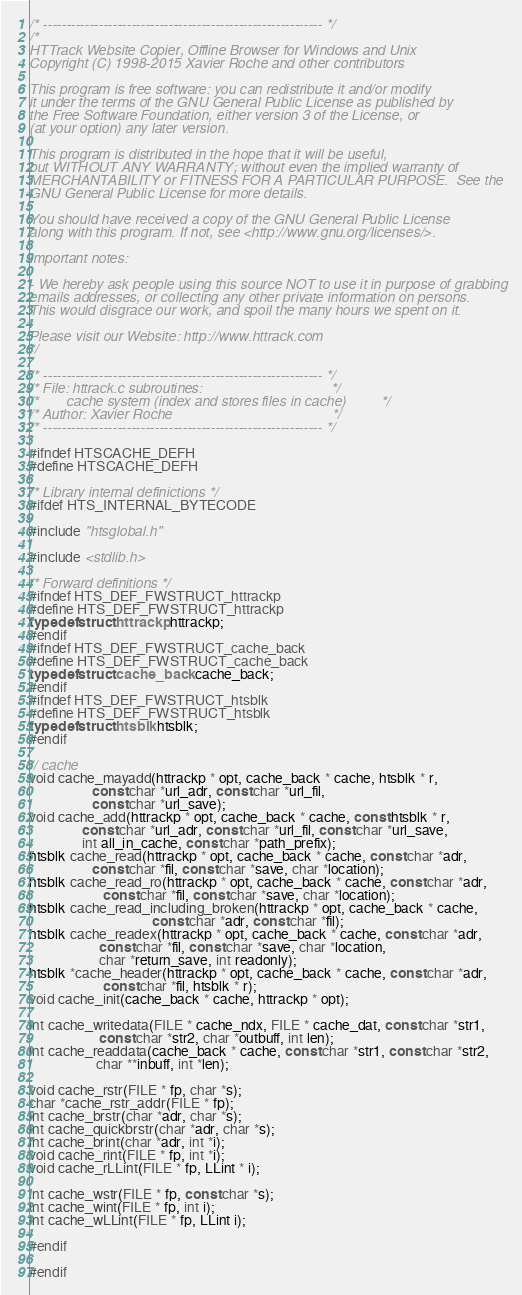Convert code to text. <code><loc_0><loc_0><loc_500><loc_500><_C_>/* ------------------------------------------------------------ */
/*
HTTrack Website Copier, Offline Browser for Windows and Unix
Copyright (C) 1998-2015 Xavier Roche and other contributors

This program is free software: you can redistribute it and/or modify
it under the terms of the GNU General Public License as published by
the Free Software Foundation, either version 3 of the License, or
(at your option) any later version.

This program is distributed in the hope that it will be useful,
but WITHOUT ANY WARRANTY; without even the implied warranty of
MERCHANTABILITY or FITNESS FOR A PARTICULAR PURPOSE.  See the
GNU General Public License for more details.

You should have received a copy of the GNU General Public License
along with this program. If not, see <http://www.gnu.org/licenses/>.

Important notes:

- We hereby ask people using this source NOT to use it in purpose of grabbing
emails addresses, or collecting any other private information on persons.
This would disgrace our work, and spoil the many hours we spent on it.

Please visit our Website: http://www.httrack.com
*/

/* ------------------------------------------------------------ */
/* File: httrack.c subroutines:                                 */
/*       cache system (index and stores files in cache)         */
/* Author: Xavier Roche                                         */
/* ------------------------------------------------------------ */

#ifndef HTSCACHE_DEFH
#define HTSCACHE_DEFH

/* Library internal definictions */
#ifdef HTS_INTERNAL_BYTECODE

#include "htsglobal.h"

#include <stdlib.h>

/* Forward definitions */
#ifndef HTS_DEF_FWSTRUCT_httrackp
#define HTS_DEF_FWSTRUCT_httrackp
typedef struct httrackp httrackp;
#endif
#ifndef HTS_DEF_FWSTRUCT_cache_back
#define HTS_DEF_FWSTRUCT_cache_back
typedef struct cache_back cache_back;
#endif
#ifndef HTS_DEF_FWSTRUCT_htsblk
#define HTS_DEF_FWSTRUCT_htsblk
typedef struct htsblk htsblk;
#endif

// cache
void cache_mayadd(httrackp * opt, cache_back * cache, htsblk * r,
                  const char *url_adr, const char *url_fil,
                  const char *url_save);
void cache_add(httrackp * opt, cache_back * cache, const htsblk * r,
               const char *url_adr, const char *url_fil, const char *url_save,
               int all_in_cache, const char *path_prefix);
htsblk cache_read(httrackp * opt, cache_back * cache, const char *adr,
                  const char *fil, const char *save, char *location);
htsblk cache_read_ro(httrackp * opt, cache_back * cache, const char *adr,
                     const char *fil, const char *save, char *location);
htsblk cache_read_including_broken(httrackp * opt, cache_back * cache,
                                   const char *adr, const char *fil);
htsblk cache_readex(httrackp * opt, cache_back * cache, const char *adr,
                    const char *fil, const char *save, char *location,
                    char *return_save, int readonly);
htsblk *cache_header(httrackp * opt, cache_back * cache, const char *adr,
                     const char *fil, htsblk * r);
void cache_init(cache_back * cache, httrackp * opt);

int cache_writedata(FILE * cache_ndx, FILE * cache_dat, const char *str1,
                    const char *str2, char *outbuff, int len);
int cache_readdata(cache_back * cache, const char *str1, const char *str2,
                   char **inbuff, int *len);

void cache_rstr(FILE * fp, char *s);
char *cache_rstr_addr(FILE * fp);
int cache_brstr(char *adr, char *s);
int cache_quickbrstr(char *adr, char *s);
int cache_brint(char *adr, int *i);
void cache_rint(FILE * fp, int *i);
void cache_rLLint(FILE * fp, LLint * i);

int cache_wstr(FILE * fp, const char *s);
int cache_wint(FILE * fp, int i);
int cache_wLLint(FILE * fp, LLint i);

#endif

#endif
</code> 